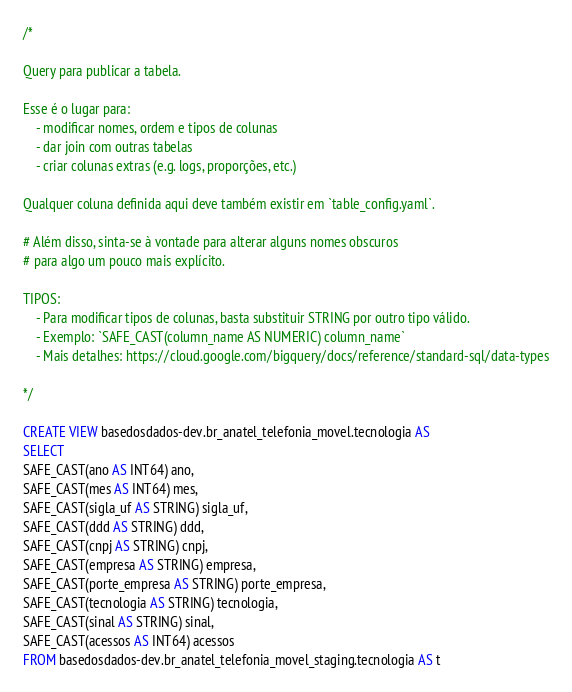<code> <loc_0><loc_0><loc_500><loc_500><_SQL_>/*

Query para publicar a tabela.

Esse é o lugar para:
    - modificar nomes, ordem e tipos de colunas
    - dar join com outras tabelas
    - criar colunas extras (e.g. logs, proporções, etc.)

Qualquer coluna definida aqui deve também existir em `table_config.yaml`.

# Além disso, sinta-se à vontade para alterar alguns nomes obscuros
# para algo um pouco mais explícito.

TIPOS:
    - Para modificar tipos de colunas, basta substituir STRING por outro tipo válido.
    - Exemplo: `SAFE_CAST(column_name AS NUMERIC) column_name`
    - Mais detalhes: https://cloud.google.com/bigquery/docs/reference/standard-sql/data-types

*/

CREATE VIEW basedosdados-dev.br_anatel_telefonia_movel.tecnologia AS
SELECT 
SAFE_CAST(ano AS INT64) ano,
SAFE_CAST(mes AS INT64) mes,
SAFE_CAST(sigla_uf AS STRING) sigla_uf,
SAFE_CAST(ddd AS STRING) ddd,
SAFE_CAST(cnpj AS STRING) cnpj,
SAFE_CAST(empresa AS STRING) empresa,
SAFE_CAST(porte_empresa AS STRING) porte_empresa,
SAFE_CAST(tecnologia AS STRING) tecnologia,
SAFE_CAST(sinal AS STRING) sinal,
SAFE_CAST(acessos AS INT64) acessos
FROM basedosdados-dev.br_anatel_telefonia_movel_staging.tecnologia AS t</code> 